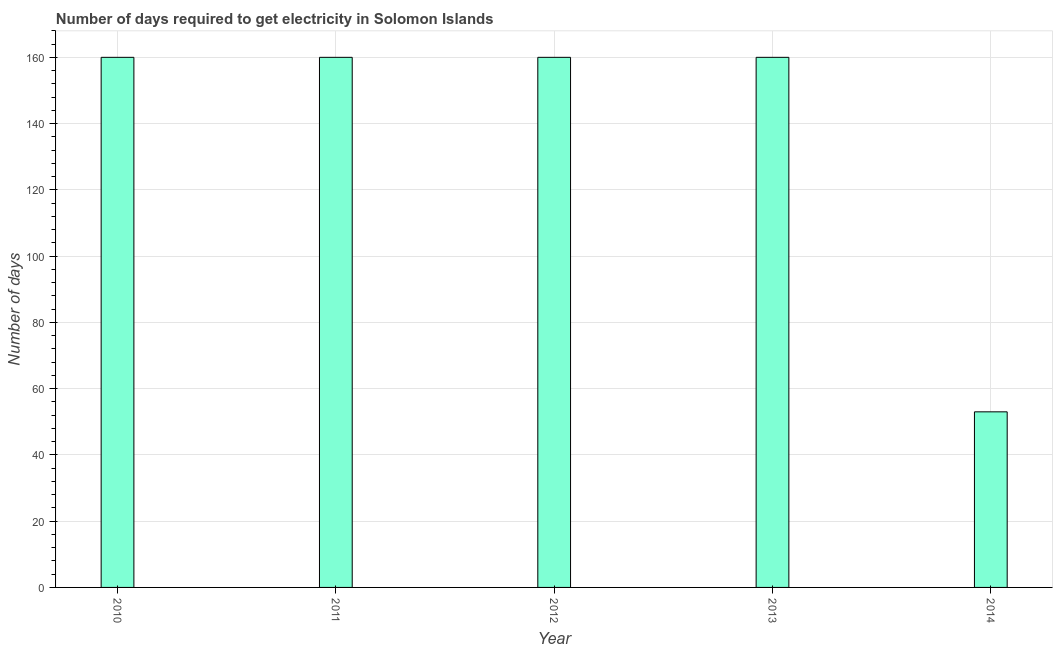What is the title of the graph?
Your answer should be very brief. Number of days required to get electricity in Solomon Islands. What is the label or title of the X-axis?
Offer a terse response. Year. What is the label or title of the Y-axis?
Your answer should be very brief. Number of days. What is the time to get electricity in 2011?
Provide a succinct answer. 160. Across all years, what is the maximum time to get electricity?
Your answer should be compact. 160. What is the sum of the time to get electricity?
Provide a short and direct response. 693. What is the difference between the time to get electricity in 2010 and 2014?
Provide a short and direct response. 107. What is the average time to get electricity per year?
Your answer should be very brief. 138. What is the median time to get electricity?
Ensure brevity in your answer.  160. Do a majority of the years between 2011 and 2010 (inclusive) have time to get electricity greater than 68 ?
Your response must be concise. No. What is the ratio of the time to get electricity in 2010 to that in 2011?
Make the answer very short. 1. Is the time to get electricity in 2011 less than that in 2012?
Make the answer very short. No. What is the difference between the highest and the second highest time to get electricity?
Your answer should be very brief. 0. Is the sum of the time to get electricity in 2013 and 2014 greater than the maximum time to get electricity across all years?
Offer a very short reply. Yes. What is the difference between the highest and the lowest time to get electricity?
Keep it short and to the point. 107. How many bars are there?
Your response must be concise. 5. How many years are there in the graph?
Give a very brief answer. 5. Are the values on the major ticks of Y-axis written in scientific E-notation?
Your answer should be compact. No. What is the Number of days in 2010?
Keep it short and to the point. 160. What is the Number of days in 2011?
Your response must be concise. 160. What is the Number of days in 2012?
Your answer should be compact. 160. What is the Number of days of 2013?
Give a very brief answer. 160. What is the difference between the Number of days in 2010 and 2011?
Your answer should be very brief. 0. What is the difference between the Number of days in 2010 and 2014?
Make the answer very short. 107. What is the difference between the Number of days in 2011 and 2012?
Offer a very short reply. 0. What is the difference between the Number of days in 2011 and 2014?
Keep it short and to the point. 107. What is the difference between the Number of days in 2012 and 2013?
Ensure brevity in your answer.  0. What is the difference between the Number of days in 2012 and 2014?
Provide a succinct answer. 107. What is the difference between the Number of days in 2013 and 2014?
Your response must be concise. 107. What is the ratio of the Number of days in 2010 to that in 2011?
Your answer should be compact. 1. What is the ratio of the Number of days in 2010 to that in 2013?
Your answer should be very brief. 1. What is the ratio of the Number of days in 2010 to that in 2014?
Give a very brief answer. 3.02. What is the ratio of the Number of days in 2011 to that in 2014?
Your response must be concise. 3.02. What is the ratio of the Number of days in 2012 to that in 2014?
Provide a succinct answer. 3.02. What is the ratio of the Number of days in 2013 to that in 2014?
Make the answer very short. 3.02. 